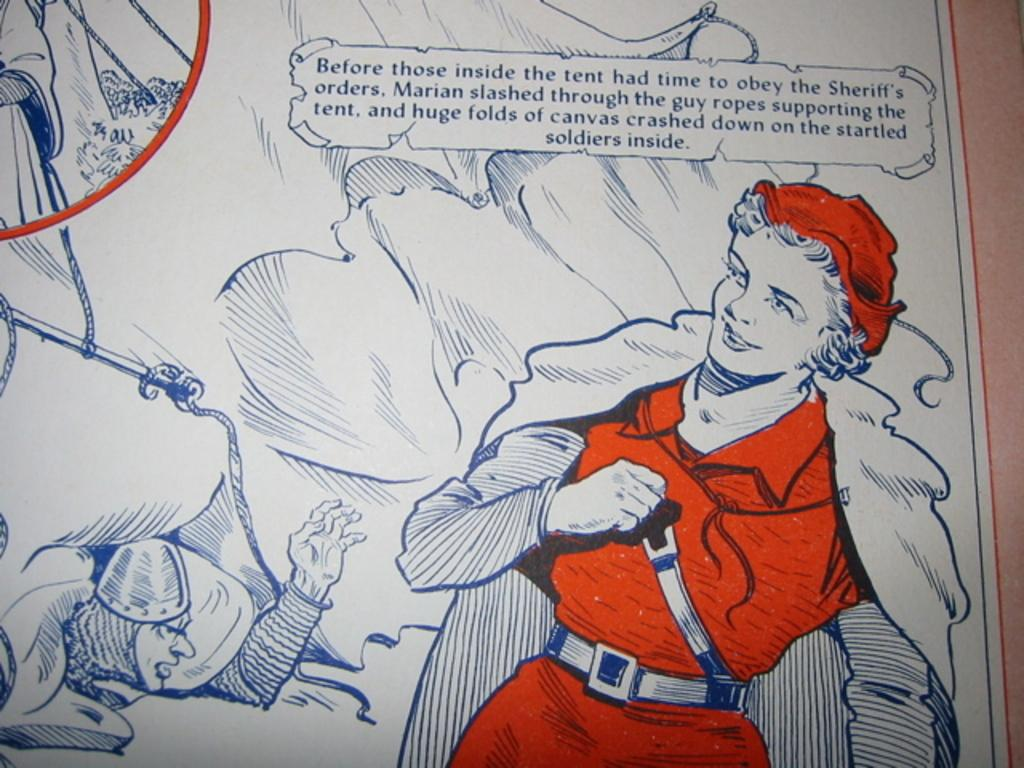Provide a one-sentence caption for the provided image. An illustrated picture with a caption that partly begins, "Before those inside the tent.". 